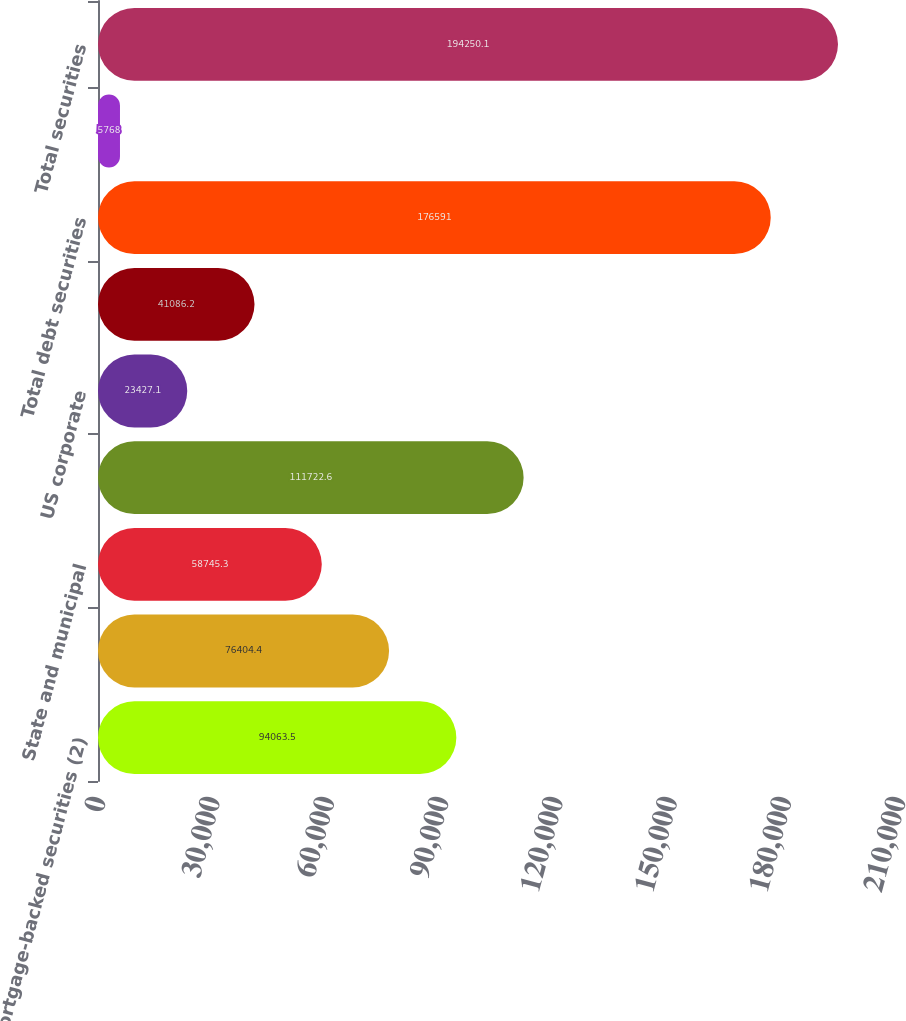<chart> <loc_0><loc_0><loc_500><loc_500><bar_chart><fcel>Mortgage-backed securities (2)<fcel>US Treasury and federal<fcel>State and municipal<fcel>Foreign government<fcel>US corporate<fcel>Other debt securities<fcel>Total debt securities<fcel>Marketable equity securities<fcel>Total securities<nl><fcel>94063.5<fcel>76404.4<fcel>58745.3<fcel>111723<fcel>23427.1<fcel>41086.2<fcel>176591<fcel>5768<fcel>194250<nl></chart> 